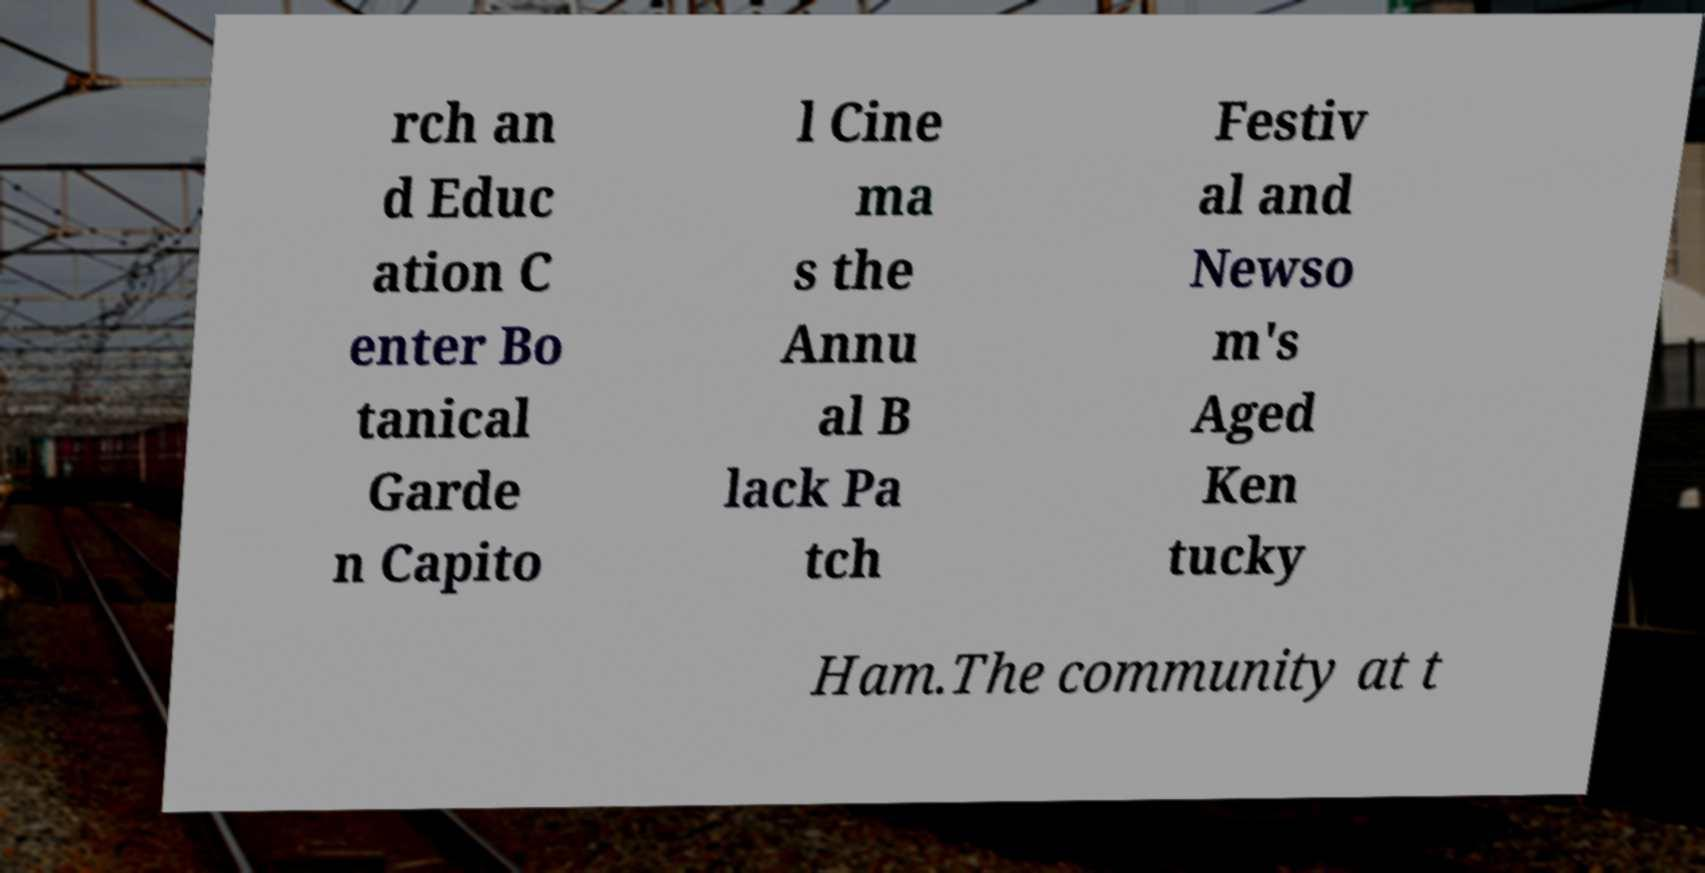There's text embedded in this image that I need extracted. Can you transcribe it verbatim? rch an d Educ ation C enter Bo tanical Garde n Capito l Cine ma s the Annu al B lack Pa tch Festiv al and Newso m's Aged Ken tucky Ham.The community at t 